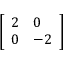Convert formula to latex. <formula><loc_0><loc_0><loc_500><loc_500>\left [ \begin{array} { l l } { 2 } & { 0 } \\ { 0 } & { - 2 } \end{array} \right ]</formula> 